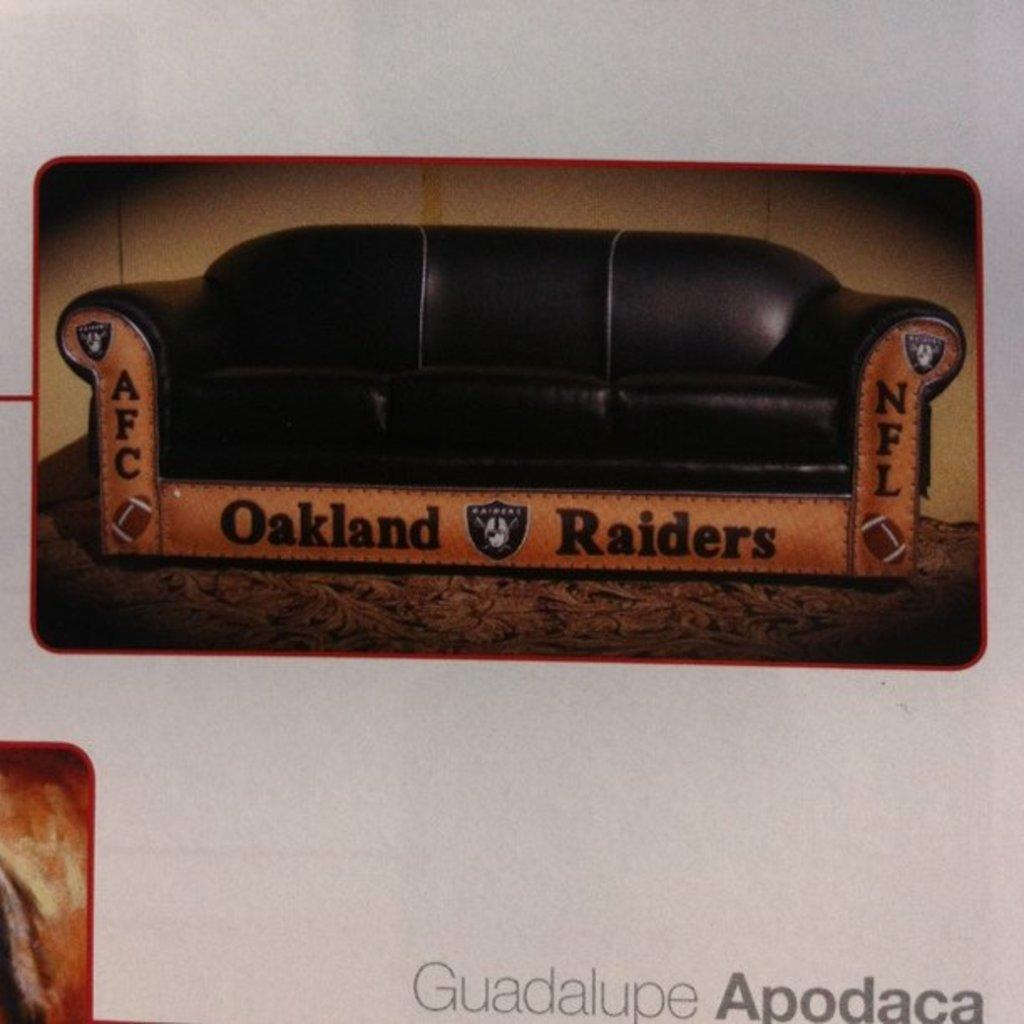What is the main object in the foreground of the poster? There is a sofa in the foreground of the poster. What is written on the sofa? The text "Oakland Raiders" is written on the sofa. Is there any text present elsewhere on the poster? Yes, there is text at the bottom side of the poster. How many pigs are visible on the sofa in the poster? There are no pigs visible on the sofa in the poster; it features the text "Oakland Raiders." What type of gate is present in the poster? There is no gate present in the poster; it features a sofa with text on it. 